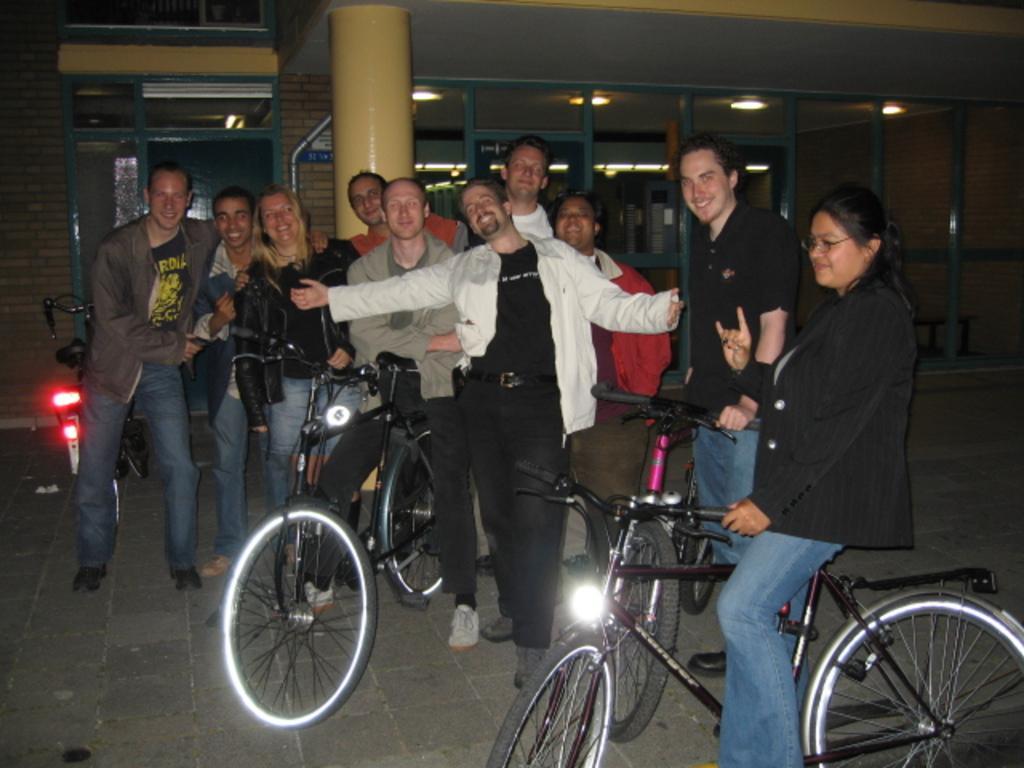Please provide a concise description of this image. In this picture there a group of people and three bicycles and in the background there is a pole and some ceiling lights and a glass door. 